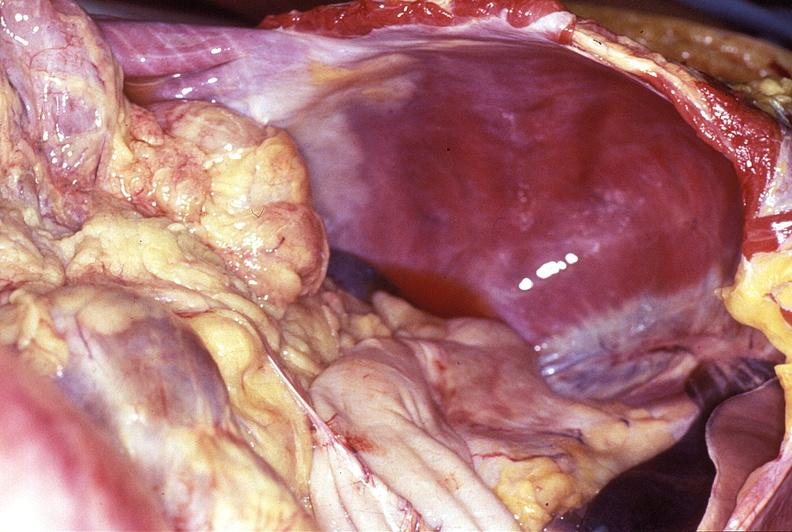does edema show intestine, volvulus?
Answer the question using a single word or phrase. No 